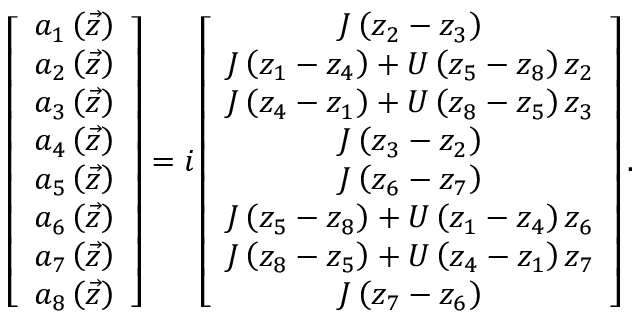<formula> <loc_0><loc_0><loc_500><loc_500>\left [ \begin{array} { c } { a _ { 1 } \left ( \vec { z } \right ) } \\ { a _ { 2 } \left ( \vec { z } \right ) } \\ { a _ { 3 } \left ( \vec { z } \right ) } \\ { a _ { 4 } \left ( \vec { z } \right ) } \\ { a _ { 5 } \left ( \vec { z } \right ) } \\ { a _ { 6 } \left ( \vec { z } \right ) } \\ { a _ { 7 } \left ( \vec { z } \right ) } \\ { a _ { 8 } \left ( \vec { z } \right ) } \end{array} \right ] = i \left [ \begin{array} { c } { J \left ( z _ { 2 } - z _ { 3 } \right ) } \\ { J \left ( z _ { 1 } - z _ { 4 } \right ) + U \left ( z _ { 5 } - z _ { 8 } \right ) z _ { 2 } } \\ { J \left ( z _ { 4 } - z _ { 1 } \right ) + U \left ( z _ { 8 } - z _ { 5 } \right ) z _ { 3 } } \\ { J \left ( z _ { 3 } - z _ { 2 } \right ) } \\ { J \left ( z _ { 6 } - z _ { 7 } \right ) } \\ { J \left ( z _ { 5 } - z _ { 8 } \right ) + U \left ( z _ { 1 } - z _ { 4 } \right ) z _ { 6 } } \\ { J \left ( z _ { 8 } - z _ { 5 } \right ) + U \left ( z _ { 4 } - z _ { 1 } \right ) z _ { 7 } } \\ { J \left ( z _ { 7 } - z _ { 6 } \right ) } \end{array} \right ] .</formula> 